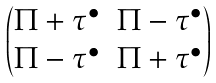Convert formula to latex. <formula><loc_0><loc_0><loc_500><loc_500>\begin{pmatrix} \Pi + \tau ^ { \bullet } & \Pi - \tau ^ { \bullet } \\ \Pi - \tau ^ { \bullet } & \Pi + \tau ^ { \bullet } \end{pmatrix}</formula> 